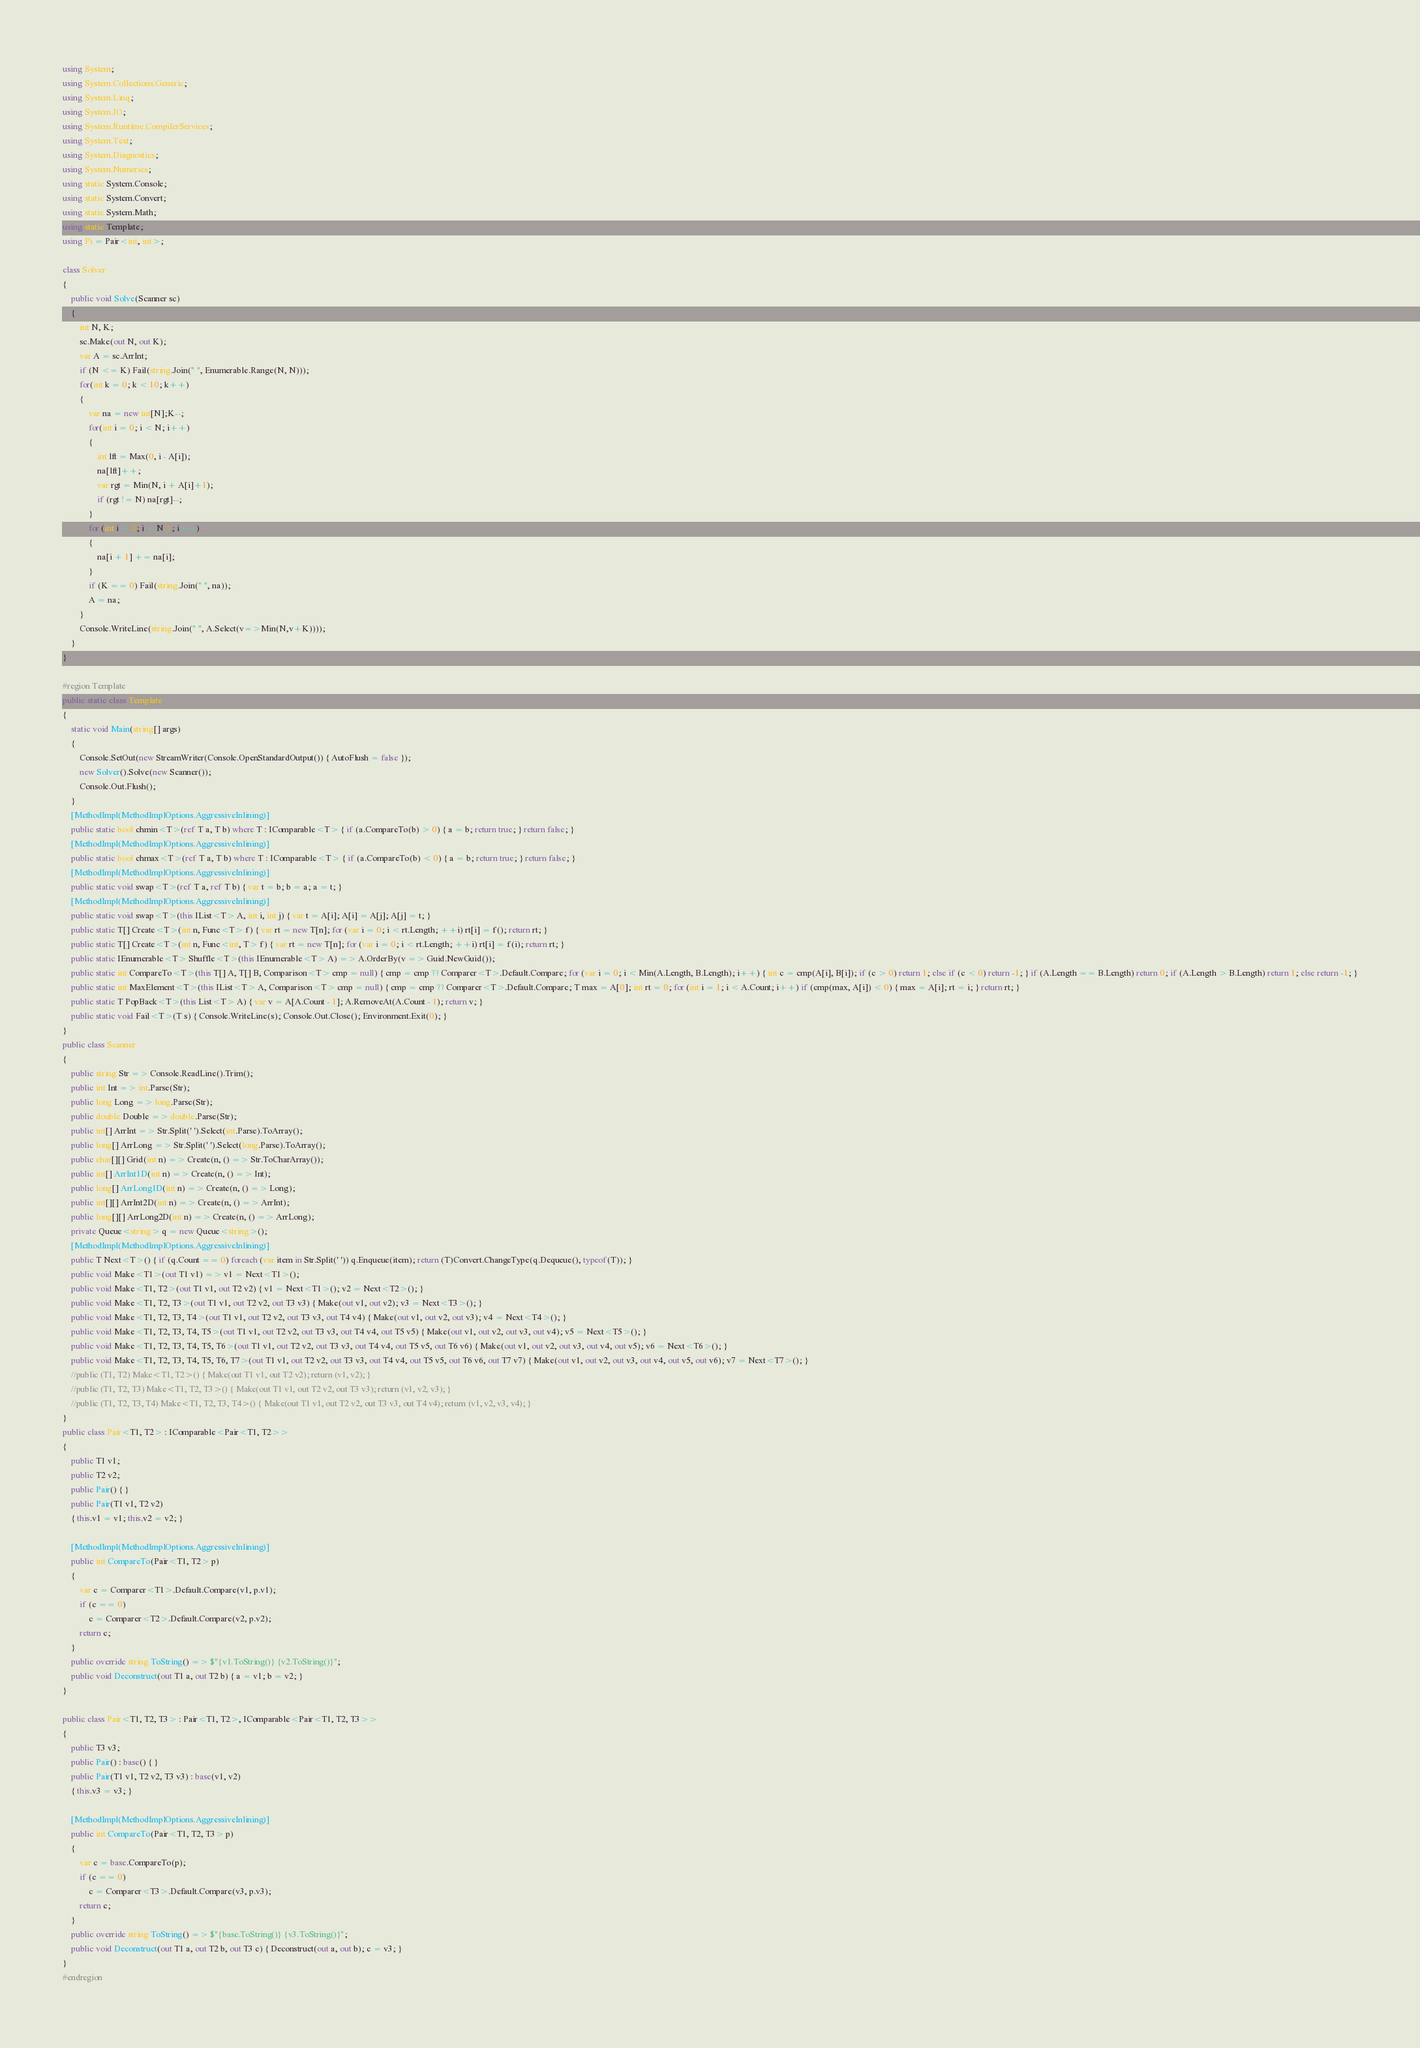Convert code to text. <code><loc_0><loc_0><loc_500><loc_500><_C#_>using System;
using System.Collections.Generic;
using System.Linq;
using System.IO;
using System.Runtime.CompilerServices;
using System.Text;
using System.Diagnostics;
using System.Numerics;
using static System.Console;
using static System.Convert;
using static System.Math;
using static Template;
using Pi = Pair<int, int>;

class Solver
{
    public void Solve(Scanner sc)
    {
        int N, K;
        sc.Make(out N, out K);
        var A = sc.ArrInt;
        if (N <= K) Fail(string.Join(" ", Enumerable.Range(N, N)));
        for(int k = 0; k < 10; k++)
        {
            var na = new int[N];K--;
            for(int i = 0; i < N; i++)
            {
                int lft = Max(0, i - A[i]);
                na[lft]++;
                var rgt = Min(N, i + A[i]+1);
                if (rgt != N) na[rgt]--;
            }
            for (int i = 0; i < N-1; i++)
            {
                na[i + 1] += na[i];
            }
            if (K == 0) Fail(string.Join(" ", na));
            A = na;
        }
        Console.WriteLine(string.Join(" ", A.Select(v=>Min(N,v+K))));
    }
}

#region Template
public static class Template
{
    static void Main(string[] args)
    {
        Console.SetOut(new StreamWriter(Console.OpenStandardOutput()) { AutoFlush = false });
        new Solver().Solve(new Scanner());
        Console.Out.Flush();
    }
    [MethodImpl(MethodImplOptions.AggressiveInlining)]
    public static bool chmin<T>(ref T a, T b) where T : IComparable<T> { if (a.CompareTo(b) > 0) { a = b; return true; } return false; }
    [MethodImpl(MethodImplOptions.AggressiveInlining)]
    public static bool chmax<T>(ref T a, T b) where T : IComparable<T> { if (a.CompareTo(b) < 0) { a = b; return true; } return false; }
    [MethodImpl(MethodImplOptions.AggressiveInlining)]
    public static void swap<T>(ref T a, ref T b) { var t = b; b = a; a = t; }
    [MethodImpl(MethodImplOptions.AggressiveInlining)]
    public static void swap<T>(this IList<T> A, int i, int j) { var t = A[i]; A[i] = A[j]; A[j] = t; }
    public static T[] Create<T>(int n, Func<T> f) { var rt = new T[n]; for (var i = 0; i < rt.Length; ++i) rt[i] = f(); return rt; }
    public static T[] Create<T>(int n, Func<int, T> f) { var rt = new T[n]; for (var i = 0; i < rt.Length; ++i) rt[i] = f(i); return rt; }
    public static IEnumerable<T> Shuffle<T>(this IEnumerable<T> A) => A.OrderBy(v => Guid.NewGuid());
    public static int CompareTo<T>(this T[] A, T[] B, Comparison<T> cmp = null) { cmp = cmp ?? Comparer<T>.Default.Compare; for (var i = 0; i < Min(A.Length, B.Length); i++) { int c = cmp(A[i], B[i]); if (c > 0) return 1; else if (c < 0) return -1; } if (A.Length == B.Length) return 0; if (A.Length > B.Length) return 1; else return -1; }
    public static int MaxElement<T>(this IList<T> A, Comparison<T> cmp = null) { cmp = cmp ?? Comparer<T>.Default.Compare; T max = A[0]; int rt = 0; for (int i = 1; i < A.Count; i++) if (cmp(max, A[i]) < 0) { max = A[i]; rt = i; } return rt; }
    public static T PopBack<T>(this List<T> A) { var v = A[A.Count - 1]; A.RemoveAt(A.Count - 1); return v; }
    public static void Fail<T>(T s) { Console.WriteLine(s); Console.Out.Close(); Environment.Exit(0); }
}
public class Scanner
{
    public string Str => Console.ReadLine().Trim();
    public int Int => int.Parse(Str);
    public long Long => long.Parse(Str);
    public double Double => double.Parse(Str);
    public int[] ArrInt => Str.Split(' ').Select(int.Parse).ToArray();
    public long[] ArrLong => Str.Split(' ').Select(long.Parse).ToArray();
    public char[][] Grid(int n) => Create(n, () => Str.ToCharArray());
    public int[] ArrInt1D(int n) => Create(n, () => Int);
    public long[] ArrLong1D(int n) => Create(n, () => Long);
    public int[][] ArrInt2D(int n) => Create(n, () => ArrInt);
    public long[][] ArrLong2D(int n) => Create(n, () => ArrLong);
    private Queue<string> q = new Queue<string>();
    [MethodImpl(MethodImplOptions.AggressiveInlining)]
    public T Next<T>() { if (q.Count == 0) foreach (var item in Str.Split(' ')) q.Enqueue(item); return (T)Convert.ChangeType(q.Dequeue(), typeof(T)); }
    public void Make<T1>(out T1 v1) => v1 = Next<T1>();
    public void Make<T1, T2>(out T1 v1, out T2 v2) { v1 = Next<T1>(); v2 = Next<T2>(); }
    public void Make<T1, T2, T3>(out T1 v1, out T2 v2, out T3 v3) { Make(out v1, out v2); v3 = Next<T3>(); }
    public void Make<T1, T2, T3, T4>(out T1 v1, out T2 v2, out T3 v3, out T4 v4) { Make(out v1, out v2, out v3); v4 = Next<T4>(); }
    public void Make<T1, T2, T3, T4, T5>(out T1 v1, out T2 v2, out T3 v3, out T4 v4, out T5 v5) { Make(out v1, out v2, out v3, out v4); v5 = Next<T5>(); }
    public void Make<T1, T2, T3, T4, T5, T6>(out T1 v1, out T2 v2, out T3 v3, out T4 v4, out T5 v5, out T6 v6) { Make(out v1, out v2, out v3, out v4, out v5); v6 = Next<T6>(); }
    public void Make<T1, T2, T3, T4, T5, T6, T7>(out T1 v1, out T2 v2, out T3 v3, out T4 v4, out T5 v5, out T6 v6, out T7 v7) { Make(out v1, out v2, out v3, out v4, out v5, out v6); v7 = Next<T7>(); }
    //public (T1, T2) Make<T1, T2>() { Make(out T1 v1, out T2 v2); return (v1, v2); }
    //public (T1, T2, T3) Make<T1, T2, T3>() { Make(out T1 v1, out T2 v2, out T3 v3); return (v1, v2, v3); }
    //public (T1, T2, T3, T4) Make<T1, T2, T3, T4>() { Make(out T1 v1, out T2 v2, out T3 v3, out T4 v4); return (v1, v2, v3, v4); }
}
public class Pair<T1, T2> : IComparable<Pair<T1, T2>>
{
    public T1 v1;
    public T2 v2;
    public Pair() { }
    public Pair(T1 v1, T2 v2)
    { this.v1 = v1; this.v2 = v2; }

    [MethodImpl(MethodImplOptions.AggressiveInlining)]
    public int CompareTo(Pair<T1, T2> p)
    {
        var c = Comparer<T1>.Default.Compare(v1, p.v1);
        if (c == 0)
            c = Comparer<T2>.Default.Compare(v2, p.v2);
        return c;
    }
    public override string ToString() => $"{v1.ToString()} {v2.ToString()}";
    public void Deconstruct(out T1 a, out T2 b) { a = v1; b = v2; }
}

public class Pair<T1, T2, T3> : Pair<T1, T2>, IComparable<Pair<T1, T2, T3>>
{
    public T3 v3;
    public Pair() : base() { }
    public Pair(T1 v1, T2 v2, T3 v3) : base(v1, v2)
    { this.v3 = v3; }

    [MethodImpl(MethodImplOptions.AggressiveInlining)]
    public int CompareTo(Pair<T1, T2, T3> p)
    {
        var c = base.CompareTo(p);
        if (c == 0)
            c = Comparer<T3>.Default.Compare(v3, p.v3);
        return c;
    }
    public override string ToString() => $"{base.ToString()} {v3.ToString()}";
    public void Deconstruct(out T1 a, out T2 b, out T3 c) { Deconstruct(out a, out b); c = v3; }
}
#endregion
</code> 